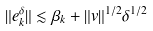Convert formula to latex. <formula><loc_0><loc_0><loc_500><loc_500>\| e _ { k } ^ { \delta } \| \lesssim \beta _ { k } + \| v \| ^ { 1 / 2 } \delta ^ { 1 / 2 }</formula> 